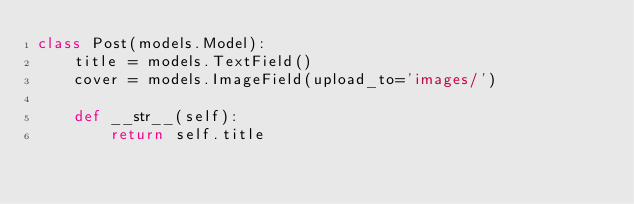Convert code to text. <code><loc_0><loc_0><loc_500><loc_500><_Python_>class Post(models.Model):
    title = models.TextField()
    cover = models.ImageField(upload_to='images/')

    def __str__(self):
        return self.title
</code> 